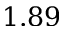<formula> <loc_0><loc_0><loc_500><loc_500>1 . 8 9</formula> 